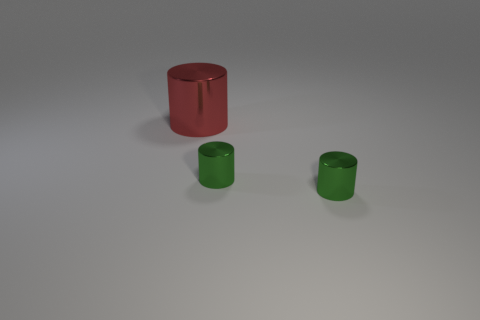What number of metal cylinders are the same size as the red object?
Offer a terse response. 0. What number of small green things have the same shape as the red object?
Provide a succinct answer. 2. What number of large gray rubber cylinders are there?
Your answer should be compact. 0. Is there a large green object made of the same material as the large cylinder?
Keep it short and to the point. No. Are there an equal number of green metal objects that are on the left side of the large shiny cylinder and cyan shiny objects?
Make the answer very short. Yes. Is there anything else that has the same size as the red cylinder?
Provide a succinct answer. No. Is there anything else that is the same shape as the large red shiny thing?
Your answer should be very brief. Yes. How many shiny objects are either big red cylinders or small green cylinders?
Provide a succinct answer. 3. Is the number of big things on the left side of the large shiny cylinder less than the number of red metallic objects?
Your answer should be very brief. Yes. Is the number of large red shiny cylinders greater than the number of cylinders?
Your answer should be compact. No. 